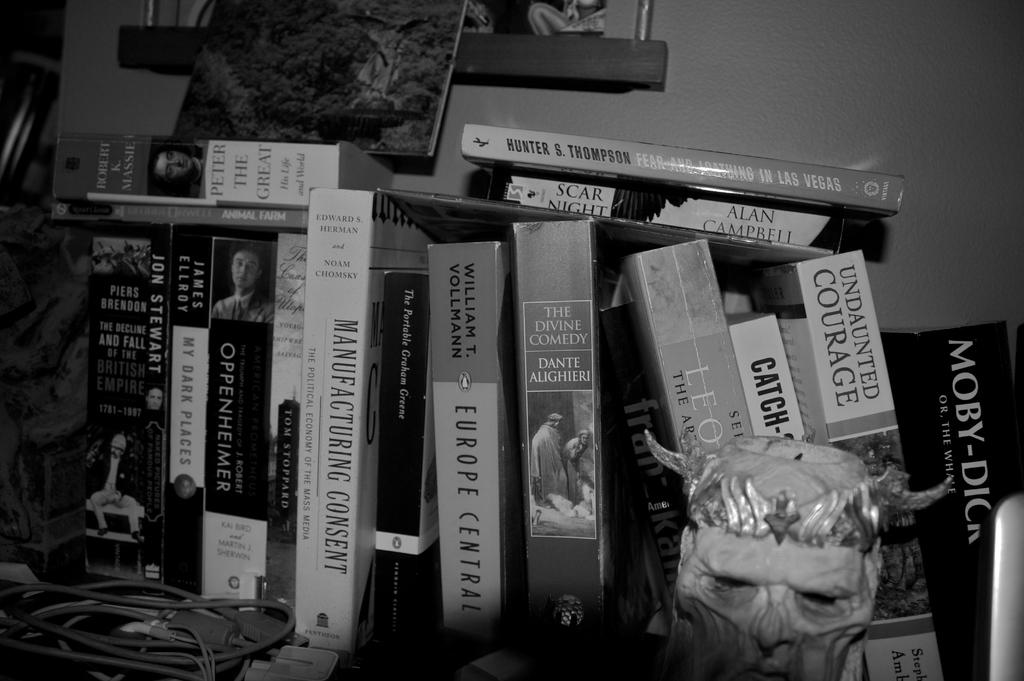<image>
Render a clear and concise summary of the photo. Europe central book, my dark places book,  moby dick book, and other books. 